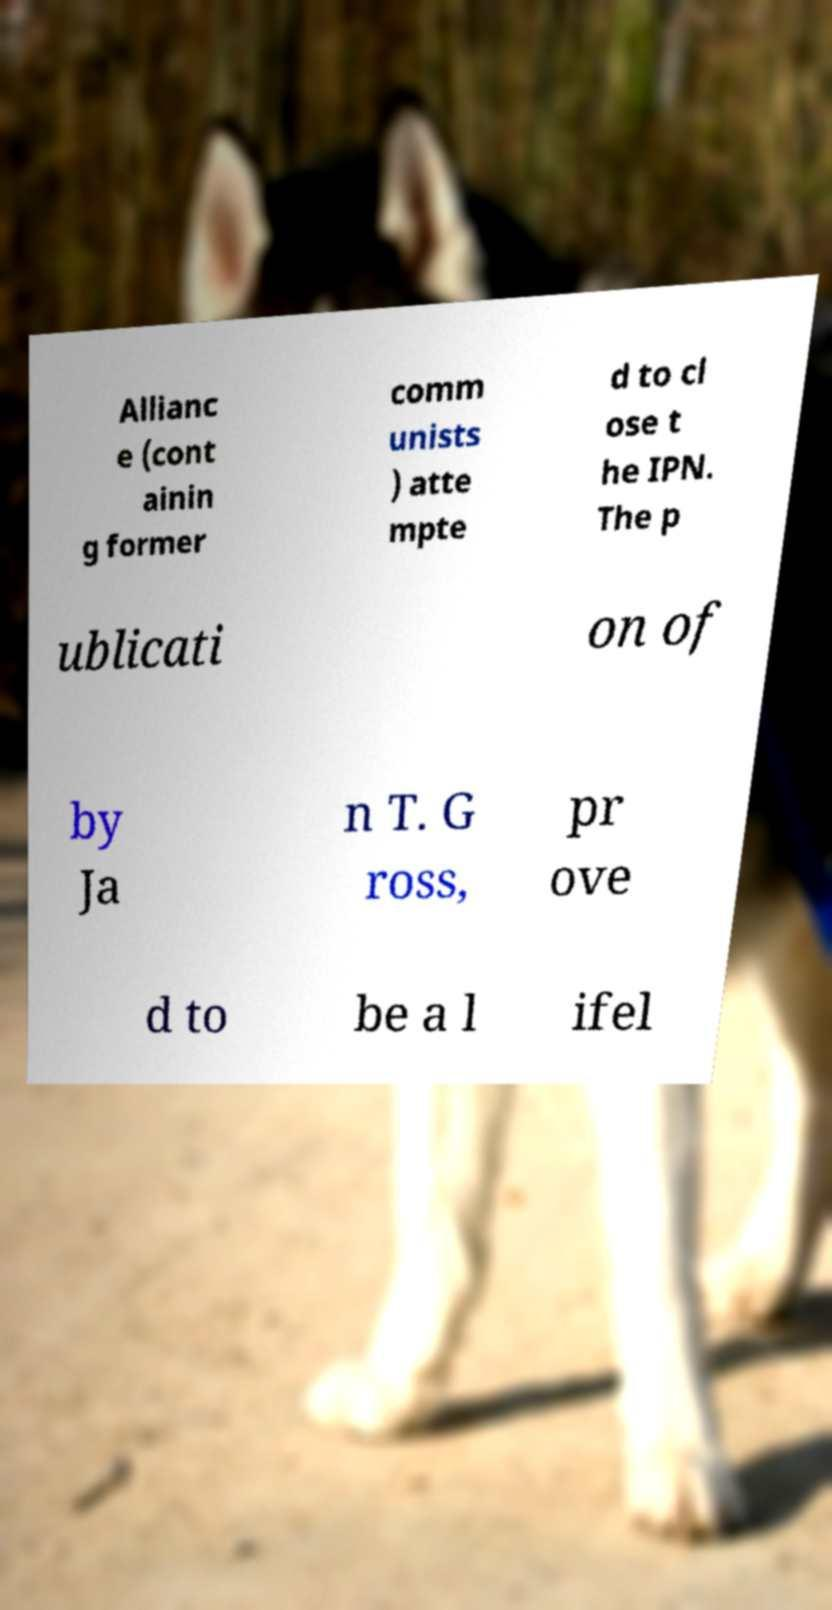What messages or text are displayed in this image? I need them in a readable, typed format. Allianc e (cont ainin g former comm unists ) atte mpte d to cl ose t he IPN. The p ublicati on of by Ja n T. G ross, pr ove d to be a l ifel 